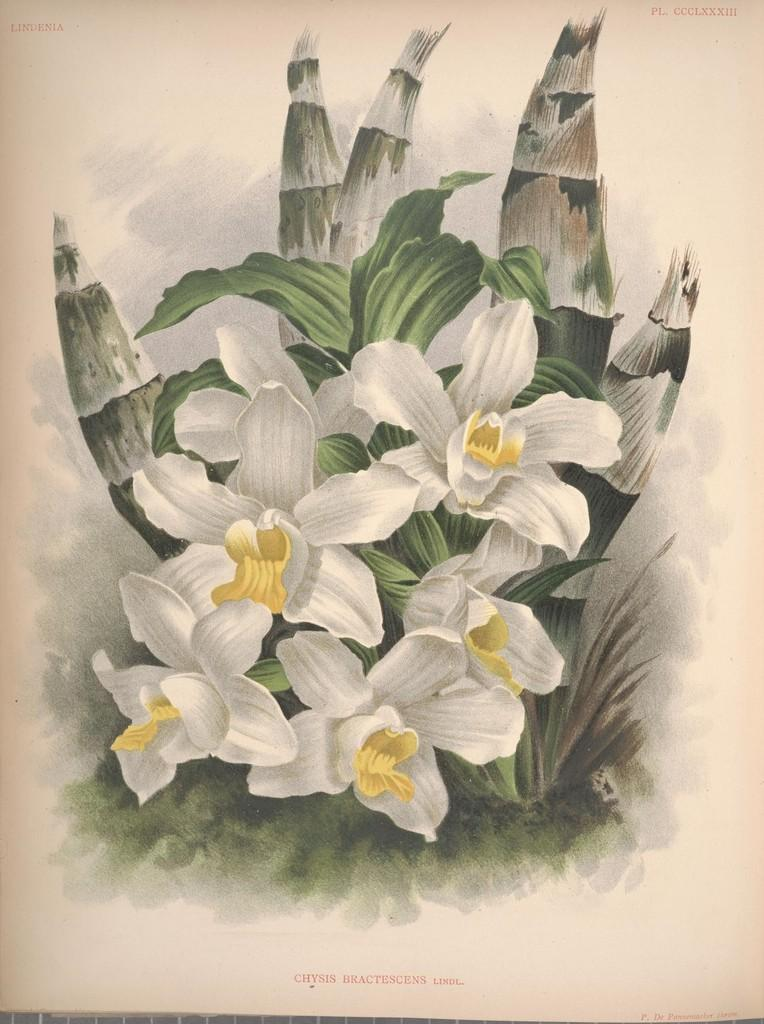What type of artwork is depicted in the image? The image is a painting. What type of flowers can be seen in the painting? There are white flowers in the painting. What other plant-related object is present in the painting? There is a plant in the painting. Can you describe any additional features of the painting? There is a watermark at the bottom of the painting. What type of farming equipment can be seen in the painting? There is no farming equipment present in the painting; it features white flowers, a plant, and a watermark. Can you describe the border around the painting? The provided facts do not mention a border around the painting, so it cannot be described. 